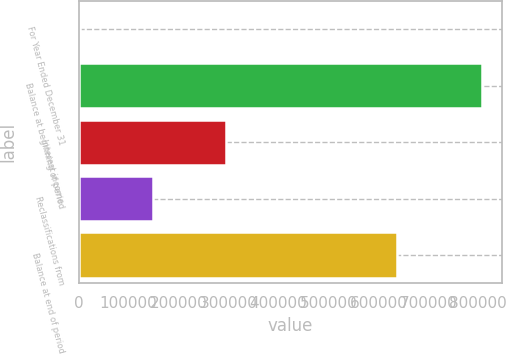<chart> <loc_0><loc_0><loc_500><loc_500><bar_chart><fcel>For Year Ended December 31<fcel>Balance at beginning of period<fcel>Interest income<fcel>Reclassifications from<fcel>Balance at end of period<nl><fcel>2012<fcel>807960<fcel>295654<fcel>148490<fcel>638272<nl></chart> 